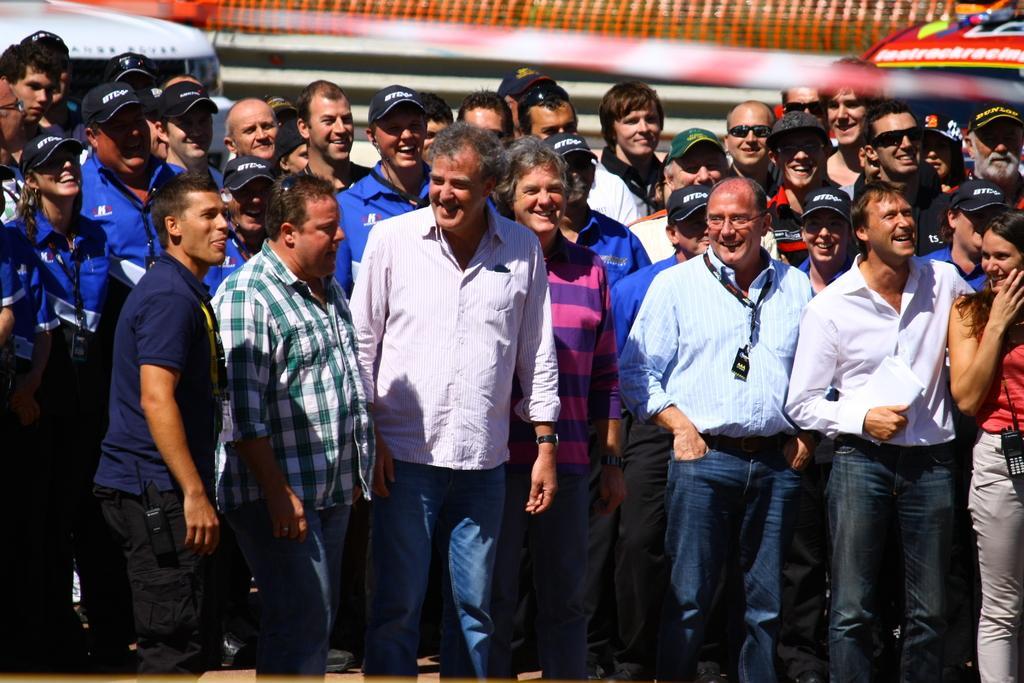In one or two sentences, can you explain what this image depicts? In this image there are so many people standing with a smile on their face. In the background there is a net fence and a few other objects. 